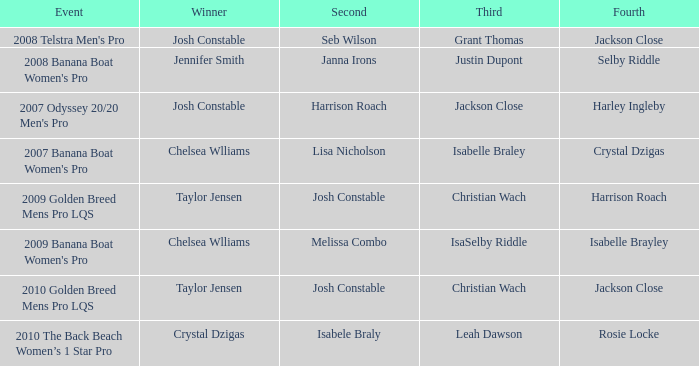Who came in fourth place at the 2008 telstra men's pro event? Jackson Close. 